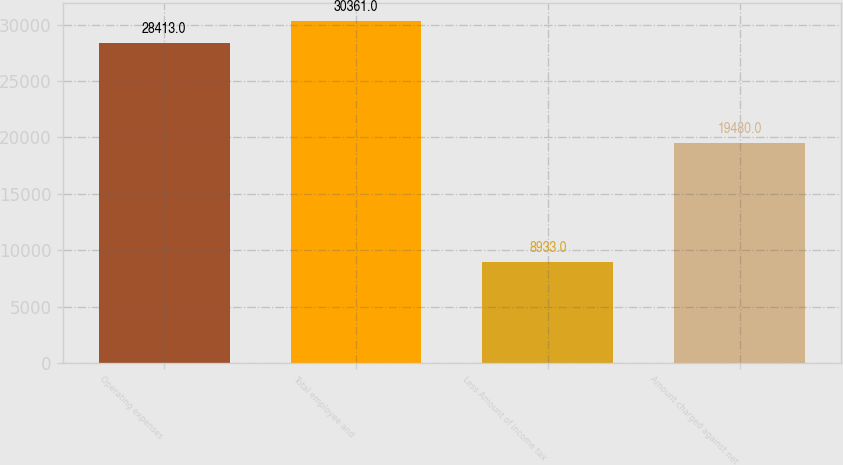<chart> <loc_0><loc_0><loc_500><loc_500><bar_chart><fcel>Operating expenses<fcel>Total employee and<fcel>Less Amount of income tax<fcel>Amount charged against net<nl><fcel>28413<fcel>30361<fcel>8933<fcel>19480<nl></chart> 